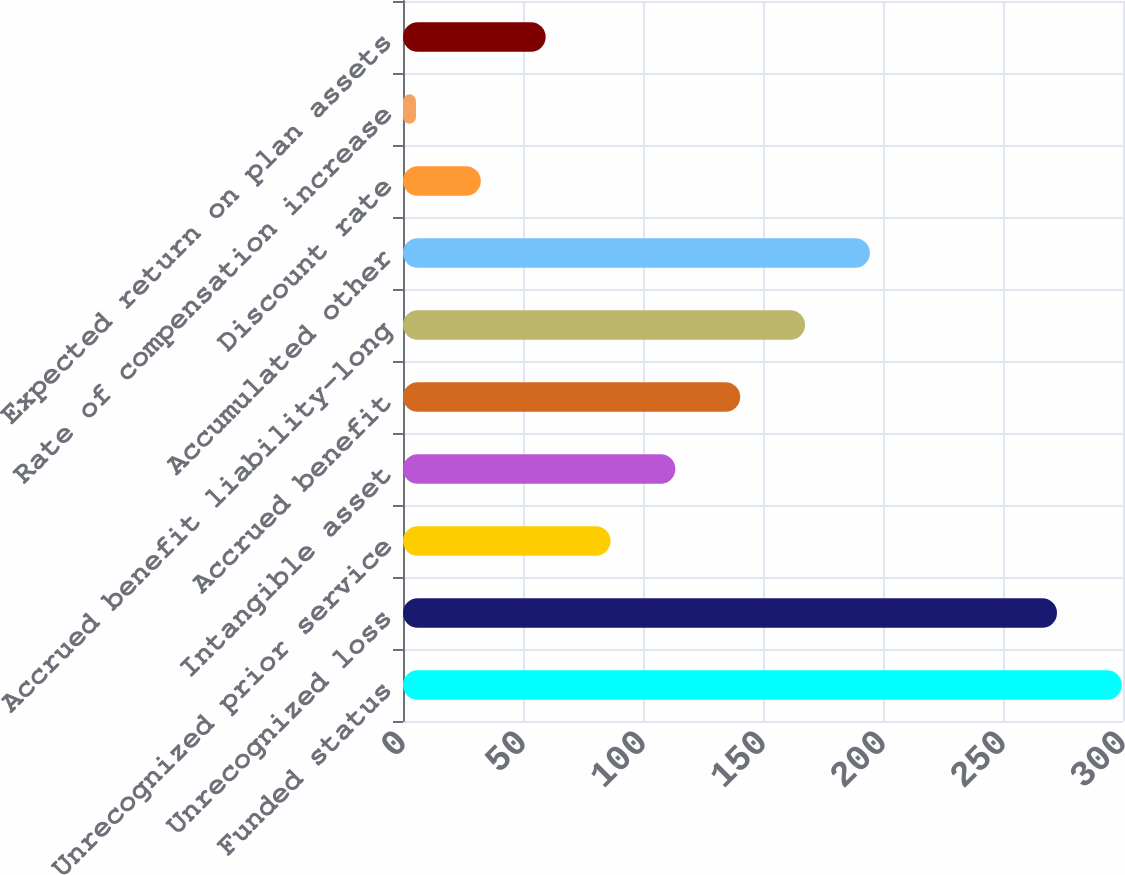Convert chart. <chart><loc_0><loc_0><loc_500><loc_500><bar_chart><fcel>Funded status<fcel>Unrecognized loss<fcel>Unrecognized prior service<fcel>Intangible asset<fcel>Accrued benefit<fcel>Accrued benefit liability-long<fcel>Accumulated other<fcel>Discount rate<fcel>Rate of compensation increase<fcel>Expected return on plan assets<nl><fcel>299.52<fcel>272.5<fcel>86.46<fcel>113.48<fcel>140.5<fcel>167.52<fcel>194.54<fcel>32.42<fcel>5.4<fcel>59.44<nl></chart> 